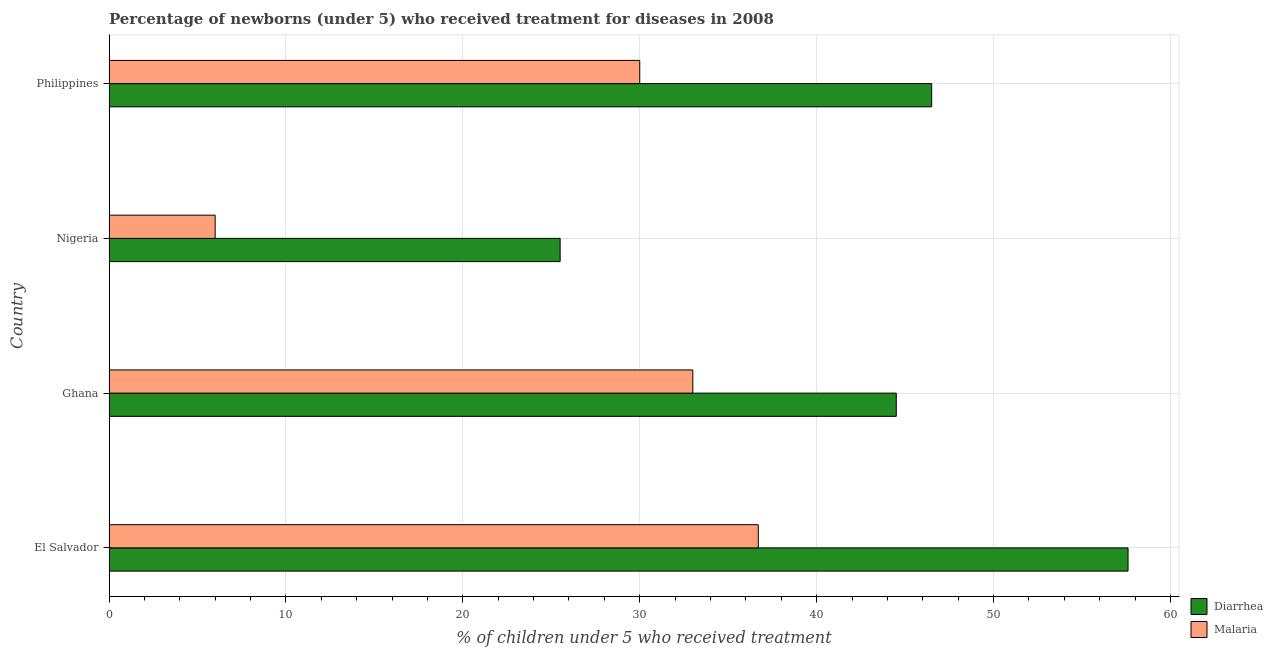Are the number of bars per tick equal to the number of legend labels?
Your response must be concise. Yes. Are the number of bars on each tick of the Y-axis equal?
Keep it short and to the point. Yes. How many bars are there on the 4th tick from the bottom?
Your answer should be compact. 2. What is the label of the 4th group of bars from the top?
Offer a terse response. El Salvador. In how many cases, is the number of bars for a given country not equal to the number of legend labels?
Your answer should be very brief. 0. What is the percentage of children who received treatment for diarrhoea in Philippines?
Provide a succinct answer. 46.5. Across all countries, what is the maximum percentage of children who received treatment for malaria?
Offer a very short reply. 36.7. Across all countries, what is the minimum percentage of children who received treatment for diarrhoea?
Provide a succinct answer. 25.5. In which country was the percentage of children who received treatment for diarrhoea maximum?
Offer a terse response. El Salvador. In which country was the percentage of children who received treatment for diarrhoea minimum?
Provide a short and direct response. Nigeria. What is the total percentage of children who received treatment for malaria in the graph?
Provide a short and direct response. 105.7. What is the difference between the percentage of children who received treatment for diarrhoea in El Salvador and that in Ghana?
Offer a very short reply. 13.1. What is the average percentage of children who received treatment for malaria per country?
Offer a terse response. 26.43. What is the difference between the percentage of children who received treatment for diarrhoea and percentage of children who received treatment for malaria in Nigeria?
Make the answer very short. 19.5. In how many countries, is the percentage of children who received treatment for diarrhoea greater than 14 %?
Offer a terse response. 4. What is the ratio of the percentage of children who received treatment for malaria in El Salvador to that in Philippines?
Your response must be concise. 1.22. Is the percentage of children who received treatment for diarrhoea in Ghana less than that in Philippines?
Make the answer very short. Yes. What is the difference between the highest and the second highest percentage of children who received treatment for malaria?
Make the answer very short. 3.7. What is the difference between the highest and the lowest percentage of children who received treatment for diarrhoea?
Ensure brevity in your answer.  32.1. In how many countries, is the percentage of children who received treatment for malaria greater than the average percentage of children who received treatment for malaria taken over all countries?
Provide a short and direct response. 3. What does the 1st bar from the top in Nigeria represents?
Give a very brief answer. Malaria. What does the 2nd bar from the bottom in Nigeria represents?
Offer a very short reply. Malaria. Are all the bars in the graph horizontal?
Your answer should be very brief. Yes. What is the difference between two consecutive major ticks on the X-axis?
Your answer should be very brief. 10. Where does the legend appear in the graph?
Keep it short and to the point. Bottom right. How many legend labels are there?
Provide a short and direct response. 2. How are the legend labels stacked?
Offer a very short reply. Vertical. What is the title of the graph?
Provide a short and direct response. Percentage of newborns (under 5) who received treatment for diseases in 2008. Does "Non-pregnant women" appear as one of the legend labels in the graph?
Make the answer very short. No. What is the label or title of the X-axis?
Make the answer very short. % of children under 5 who received treatment. What is the label or title of the Y-axis?
Offer a terse response. Country. What is the % of children under 5 who received treatment of Diarrhea in El Salvador?
Give a very brief answer. 57.6. What is the % of children under 5 who received treatment of Malaria in El Salvador?
Provide a short and direct response. 36.7. What is the % of children under 5 who received treatment of Diarrhea in Ghana?
Keep it short and to the point. 44.5. What is the % of children under 5 who received treatment in Malaria in Ghana?
Offer a very short reply. 33. What is the % of children under 5 who received treatment in Diarrhea in Philippines?
Ensure brevity in your answer.  46.5. Across all countries, what is the maximum % of children under 5 who received treatment of Diarrhea?
Give a very brief answer. 57.6. Across all countries, what is the maximum % of children under 5 who received treatment of Malaria?
Keep it short and to the point. 36.7. What is the total % of children under 5 who received treatment of Diarrhea in the graph?
Keep it short and to the point. 174.1. What is the total % of children under 5 who received treatment in Malaria in the graph?
Offer a terse response. 105.7. What is the difference between the % of children under 5 who received treatment in Diarrhea in El Salvador and that in Nigeria?
Your answer should be very brief. 32.1. What is the difference between the % of children under 5 who received treatment of Malaria in El Salvador and that in Nigeria?
Give a very brief answer. 30.7. What is the difference between the % of children under 5 who received treatment in Malaria in El Salvador and that in Philippines?
Your answer should be very brief. 6.7. What is the difference between the % of children under 5 who received treatment in Malaria in Ghana and that in Nigeria?
Your answer should be compact. 27. What is the difference between the % of children under 5 who received treatment of Diarrhea in Nigeria and that in Philippines?
Your answer should be very brief. -21. What is the difference between the % of children under 5 who received treatment in Malaria in Nigeria and that in Philippines?
Your answer should be very brief. -24. What is the difference between the % of children under 5 who received treatment in Diarrhea in El Salvador and the % of children under 5 who received treatment in Malaria in Ghana?
Your answer should be compact. 24.6. What is the difference between the % of children under 5 who received treatment of Diarrhea in El Salvador and the % of children under 5 who received treatment of Malaria in Nigeria?
Keep it short and to the point. 51.6. What is the difference between the % of children under 5 who received treatment of Diarrhea in El Salvador and the % of children under 5 who received treatment of Malaria in Philippines?
Offer a terse response. 27.6. What is the difference between the % of children under 5 who received treatment of Diarrhea in Ghana and the % of children under 5 who received treatment of Malaria in Nigeria?
Provide a succinct answer. 38.5. What is the difference between the % of children under 5 who received treatment of Diarrhea in Ghana and the % of children under 5 who received treatment of Malaria in Philippines?
Provide a succinct answer. 14.5. What is the average % of children under 5 who received treatment of Diarrhea per country?
Provide a succinct answer. 43.52. What is the average % of children under 5 who received treatment in Malaria per country?
Keep it short and to the point. 26.43. What is the difference between the % of children under 5 who received treatment in Diarrhea and % of children under 5 who received treatment in Malaria in El Salvador?
Your answer should be compact. 20.9. What is the difference between the % of children under 5 who received treatment of Diarrhea and % of children under 5 who received treatment of Malaria in Nigeria?
Make the answer very short. 19.5. What is the ratio of the % of children under 5 who received treatment in Diarrhea in El Salvador to that in Ghana?
Provide a succinct answer. 1.29. What is the ratio of the % of children under 5 who received treatment in Malaria in El Salvador to that in Ghana?
Give a very brief answer. 1.11. What is the ratio of the % of children under 5 who received treatment of Diarrhea in El Salvador to that in Nigeria?
Keep it short and to the point. 2.26. What is the ratio of the % of children under 5 who received treatment in Malaria in El Salvador to that in Nigeria?
Your answer should be compact. 6.12. What is the ratio of the % of children under 5 who received treatment of Diarrhea in El Salvador to that in Philippines?
Offer a terse response. 1.24. What is the ratio of the % of children under 5 who received treatment in Malaria in El Salvador to that in Philippines?
Offer a terse response. 1.22. What is the ratio of the % of children under 5 who received treatment of Diarrhea in Ghana to that in Nigeria?
Offer a terse response. 1.75. What is the ratio of the % of children under 5 who received treatment of Malaria in Ghana to that in Nigeria?
Give a very brief answer. 5.5. What is the ratio of the % of children under 5 who received treatment of Diarrhea in Ghana to that in Philippines?
Provide a succinct answer. 0.96. What is the ratio of the % of children under 5 who received treatment in Diarrhea in Nigeria to that in Philippines?
Your answer should be compact. 0.55. What is the difference between the highest and the second highest % of children under 5 who received treatment of Malaria?
Your response must be concise. 3.7. What is the difference between the highest and the lowest % of children under 5 who received treatment in Diarrhea?
Your answer should be compact. 32.1. What is the difference between the highest and the lowest % of children under 5 who received treatment of Malaria?
Your answer should be compact. 30.7. 